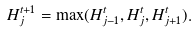<formula> <loc_0><loc_0><loc_500><loc_500>H _ { j } ^ { t + 1 } = \max ( H _ { j - 1 } ^ { t } , H _ { j } ^ { t } , H _ { j + 1 } ^ { t } ) .</formula> 